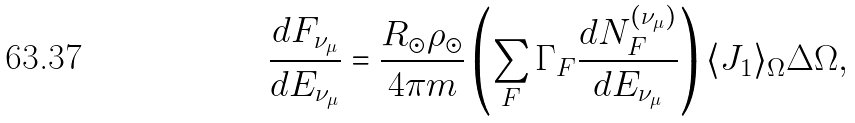Convert formula to latex. <formula><loc_0><loc_0><loc_500><loc_500>\frac { d F _ { \nu _ { \mu } } } { d E _ { \nu _ { \mu } } } = \frac { R _ { \odot } \rho _ { \odot } } { 4 \pi m } \left ( \sum _ { F } \Gamma _ { F } \frac { d N _ { F } ^ { ( \nu _ { \mu } ) } } { d E _ { \nu _ { \mu } } } \right ) \langle J _ { 1 } \rangle _ { \Omega } \Delta \Omega ,</formula> 